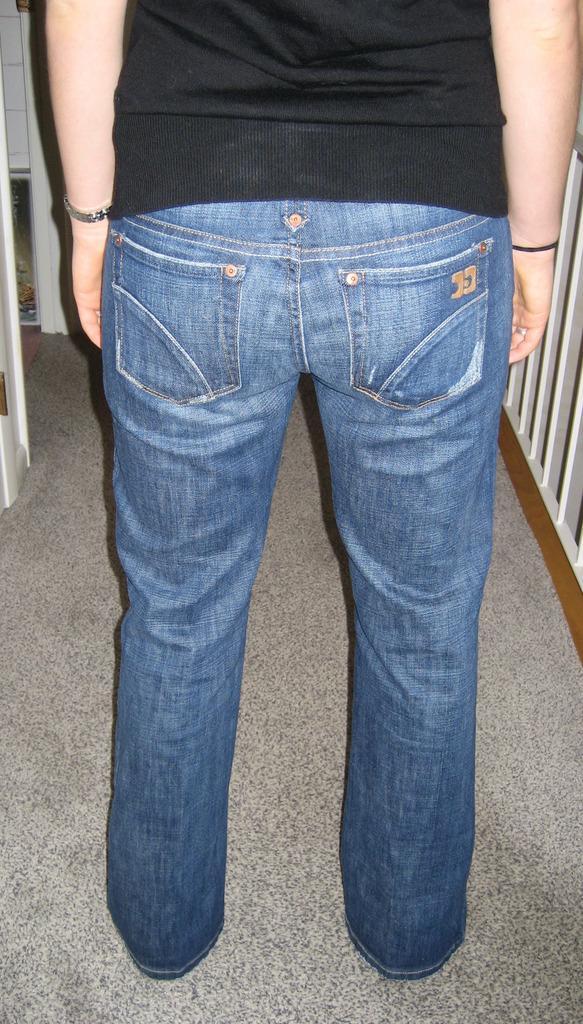Can you describe this image briefly? In this image I can see a person standing on the floor and in the background there are some objects. 